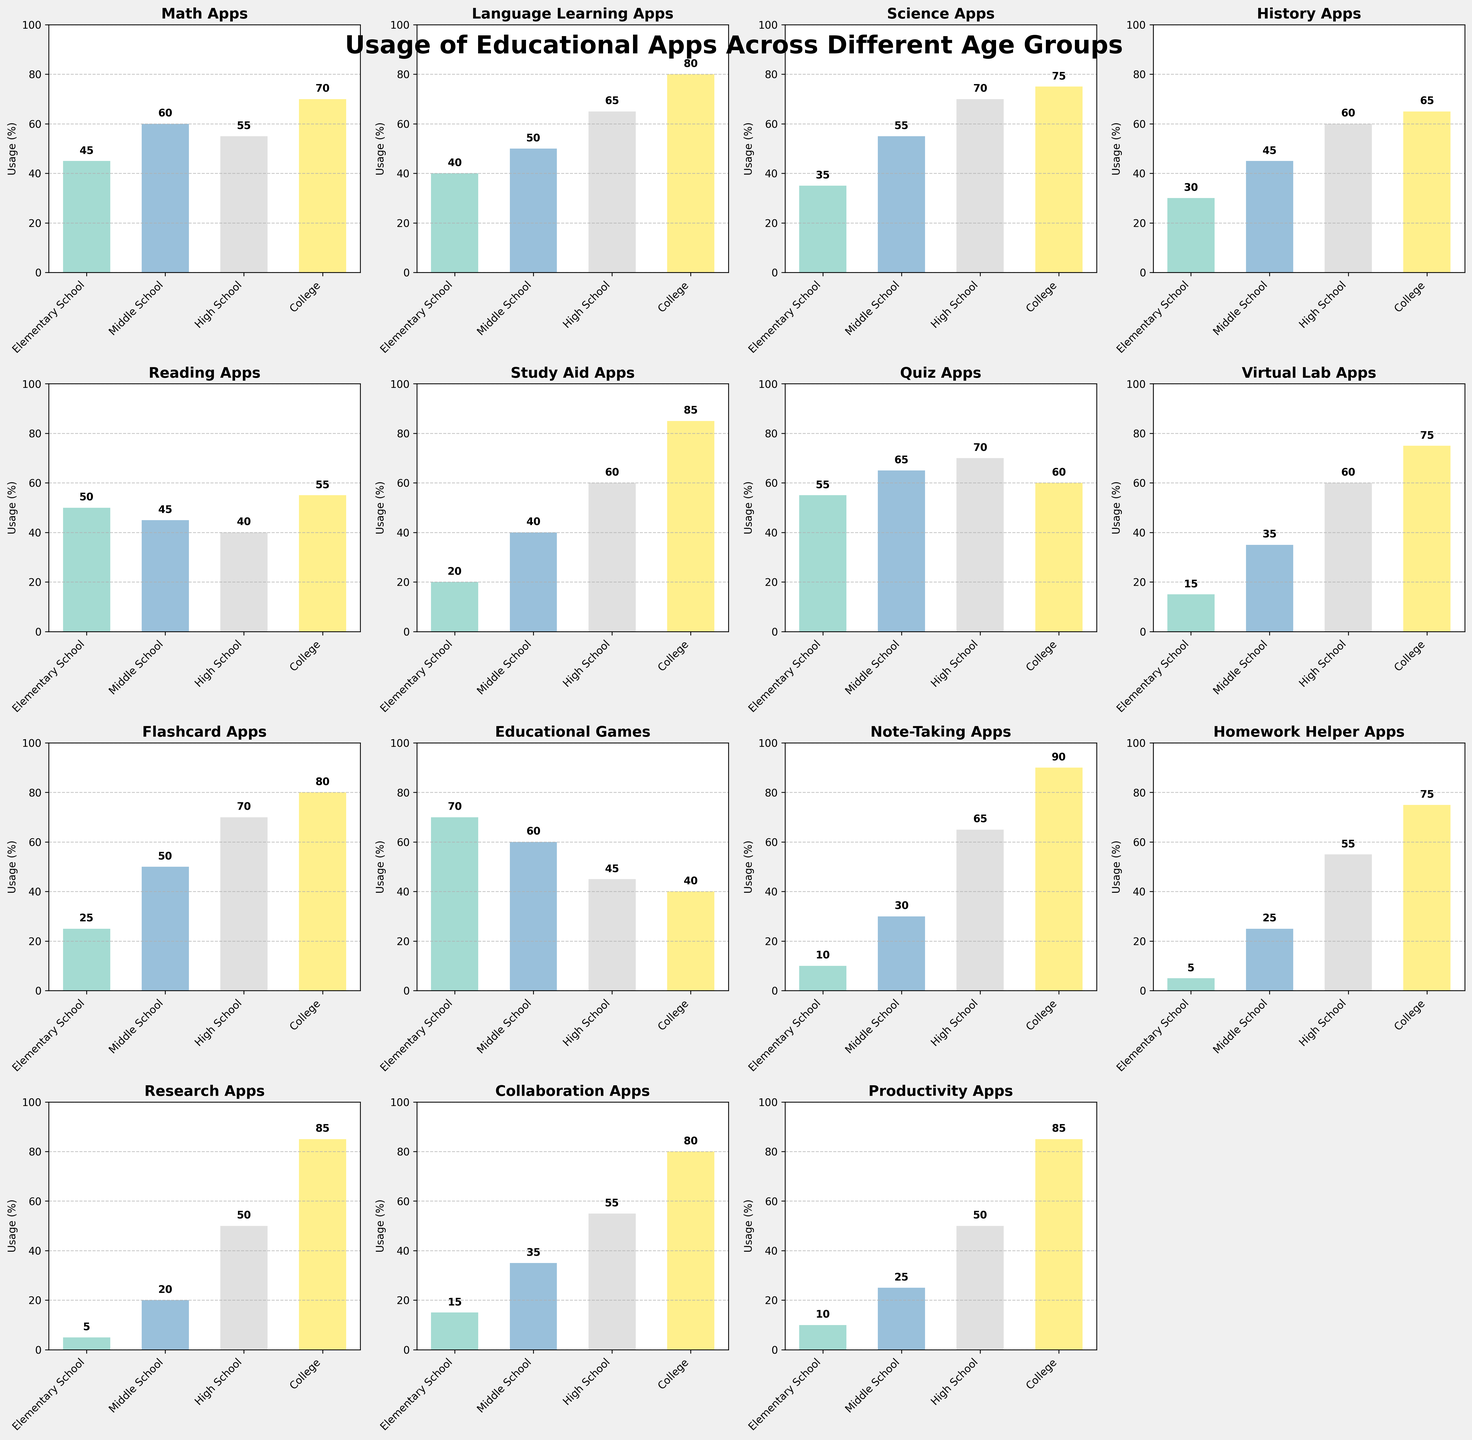Which age group uses 'Note-Taking Apps' the most? Looking at the subplot titled 'Note-Taking Apps,' we see the highest bar representing 'College' with a value of 90%.
Answer: College Are 'Math Apps' more popular in Middle School or High School? Referring to the subplot titled 'Math Apps,' the bar for Middle School is at 60%, while the bar for High School is at 55%. Middle School has a higher value.
Answer: Middle School What's the average usage of 'Quiz Apps' across all age groups? Adding the values for 'Quiz Apps': 55 (Elementary School) + 65 (Middle School) + 70 (High School) + 60 (College) = 250. The average is 250/4 = 62.5%.
Answer: 62.5% Which app has the least usage in Elementary School? Looking at all subplots and focusing on the 'Elementary School' bars, 'Homework Helper Apps' have the smallest bar with a value of 5%.
Answer: Homework Helper Apps Compare the usage of 'Educational Games' between Elementary School and College. In the subplot for 'Educational Games,' the bar for Elementary School is at 70%, while for College, it is at 40%. Elementary School has a higher usage.
Answer: Elementary School Is the usage of 'Science Apps' in High School higher than in College? The 'Science Apps' subplot shows the bar for High School at 70% and for College at 75%. Thus, usage in College is higher.
Answer: No What's the difference in usage of 'Virtual Lab Apps' between Middle School and College? In the 'Virtual Lab Apps' subplot, the usage for Middle School is 35%, and for College, it is 75%. The difference is 75 - 35 = 40%.
Answer: 40% Which age group has the highest usage of 'Study Aid Apps'? Looking at the 'Study Aid Apps' subplot, the bar for College is the highest at 85%.
Answer: College Calculate the total usage of 'Language Learning Apps' across all age groups. Adding the values for 'Language Learning Apps': 40 (Elementary School) + 50 (Middle School) + 65 (High School) + 80 (College) = 235%.
Answer: 235% Identify the app with the highest usage in High School. By examining all subplots, 'Quiz Apps' and 'Flashcard Apps' have the highest bars in High School, both at 70%. There is a tie.
Answer: Quiz Apps and Flashcard Apps 